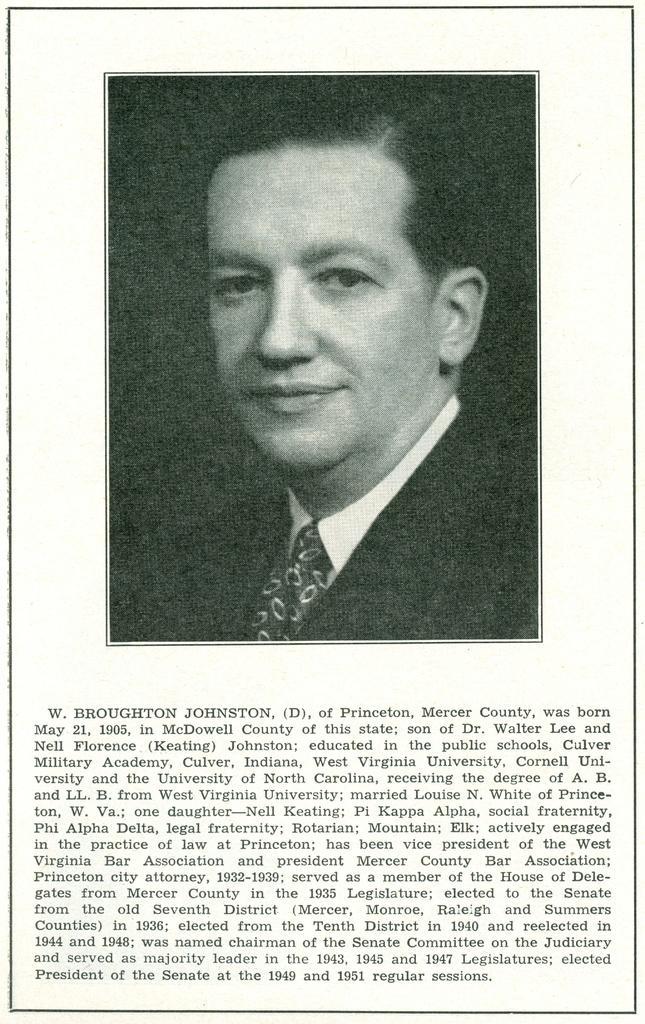Could you give a brief overview of what you see in this image? In this image I can see a person's photo and a text. This image looks like a photo frame. 